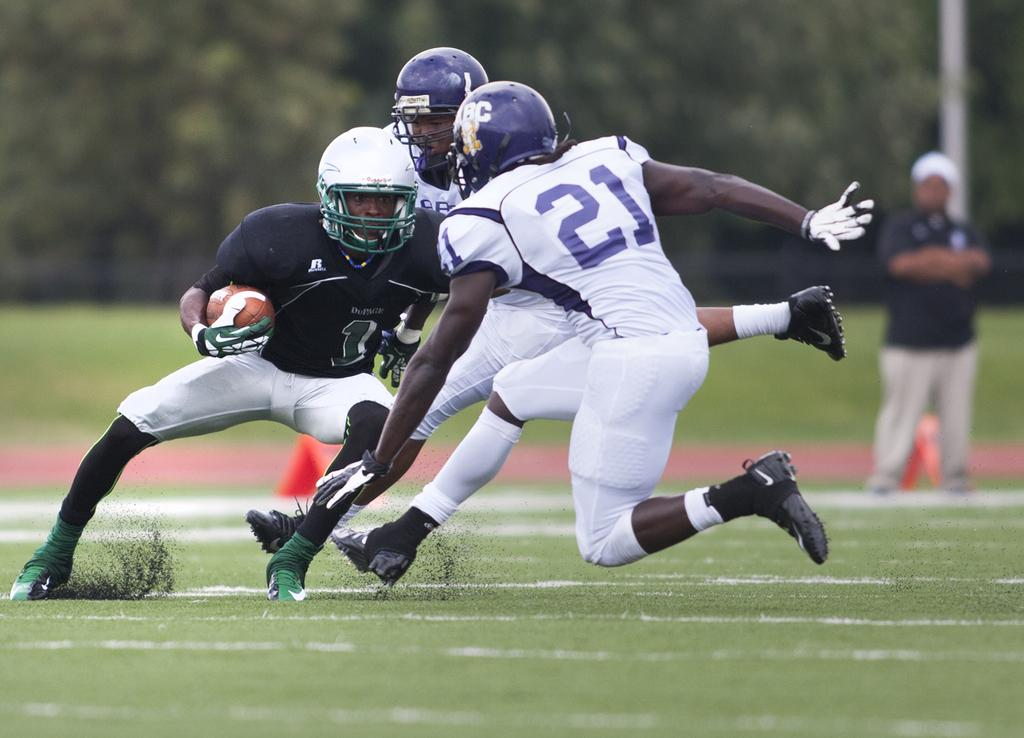What sport are the three men in the foreground of the image playing? The three men are playing rugby in the foreground of the image. What surface are they playing on? They are playing on the grass. Can you describe the background of the image? There is a man standing and a pole visible in the background, along with greenery. What type of cracker is being used as a prop in the rugby game? There is no cracker present in the image, and no props are mentioned in the provided facts. 